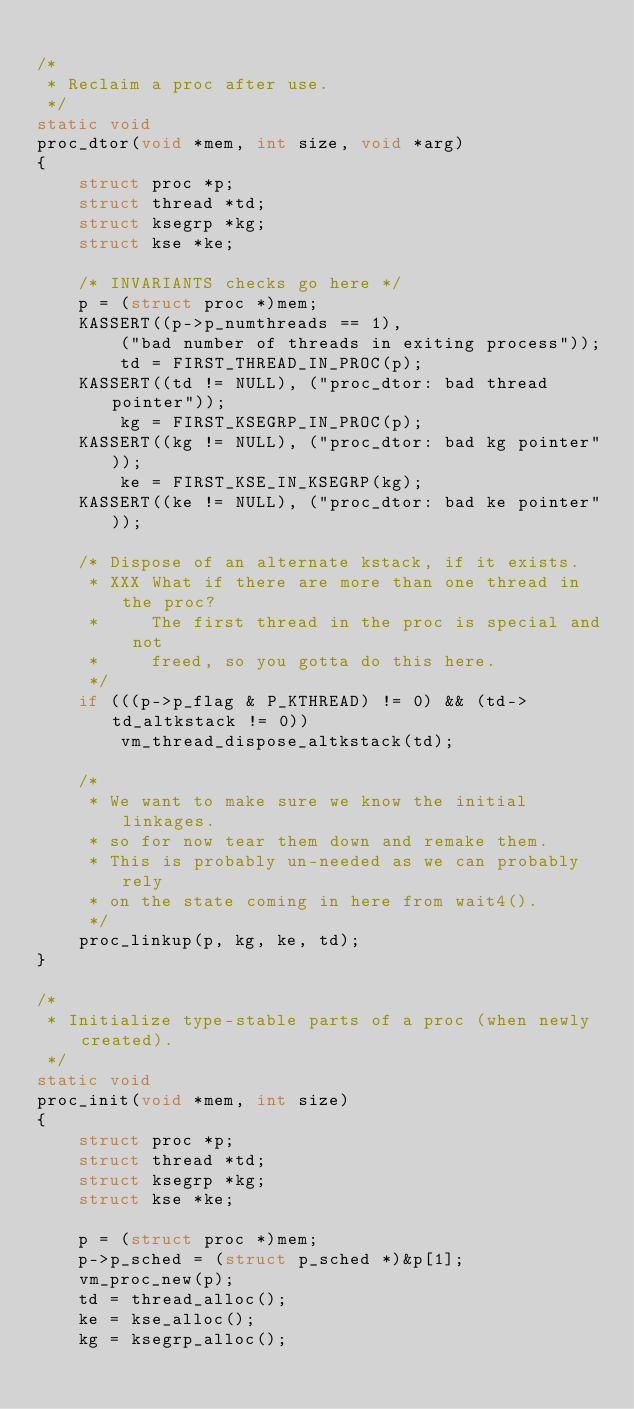Convert code to text. <code><loc_0><loc_0><loc_500><loc_500><_C_>
/*
 * Reclaim a proc after use.
 */
static void
proc_dtor(void *mem, int size, void *arg)
{
	struct proc *p;
	struct thread *td;
	struct ksegrp *kg;
	struct kse *ke;

	/* INVARIANTS checks go here */
	p = (struct proc *)mem;
	KASSERT((p->p_numthreads == 1),
	    ("bad number of threads in exiting process"));
        td = FIRST_THREAD_IN_PROC(p);
	KASSERT((td != NULL), ("proc_dtor: bad thread pointer"));
        kg = FIRST_KSEGRP_IN_PROC(p);
	KASSERT((kg != NULL), ("proc_dtor: bad kg pointer"));
        ke = FIRST_KSE_IN_KSEGRP(kg);
	KASSERT((ke != NULL), ("proc_dtor: bad ke pointer"));

	/* Dispose of an alternate kstack, if it exists.
	 * XXX What if there are more than one thread in the proc?
	 *     The first thread in the proc is special and not
	 *     freed, so you gotta do this here.
	 */
	if (((p->p_flag & P_KTHREAD) != 0) && (td->td_altkstack != 0))
		vm_thread_dispose_altkstack(td);

	/*
	 * We want to make sure we know the initial linkages.
	 * so for now tear them down and remake them.
	 * This is probably un-needed as we can probably rely
	 * on the state coming in here from wait4().
	 */
	proc_linkup(p, kg, ke, td);
}

/*
 * Initialize type-stable parts of a proc (when newly created).
 */
static void
proc_init(void *mem, int size)
{
	struct proc *p;
	struct thread *td;
	struct ksegrp *kg;
	struct kse *ke;

	p = (struct proc *)mem;
	p->p_sched = (struct p_sched *)&p[1];
	vm_proc_new(p);
	td = thread_alloc();
	ke = kse_alloc();
	kg = ksegrp_alloc();</code> 